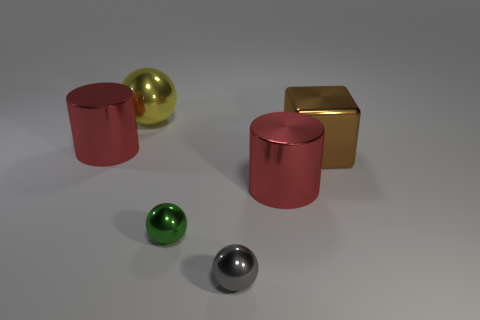There is a object on the right side of the big metal cylinder on the right side of the yellow sphere; what color is it?
Give a very brief answer. Brown. How many large purple metal cubes are there?
Ensure brevity in your answer.  0. How many things are on the left side of the yellow object and in front of the green ball?
Provide a short and direct response. 0. Is there anything else that has the same shape as the green object?
Ensure brevity in your answer.  Yes. There is a shiny block; is it the same color as the metal cylinder in front of the large brown shiny cube?
Make the answer very short. No. What is the shape of the red metal object right of the big yellow sphere?
Keep it short and to the point. Cylinder. What number of other things are there of the same material as the brown block
Provide a succinct answer. 5. What material is the small gray object?
Make the answer very short. Metal. What number of large objects are either green metallic cubes or brown cubes?
Your answer should be very brief. 1. There is a brown cube; what number of large yellow metal things are in front of it?
Your answer should be very brief. 0. 